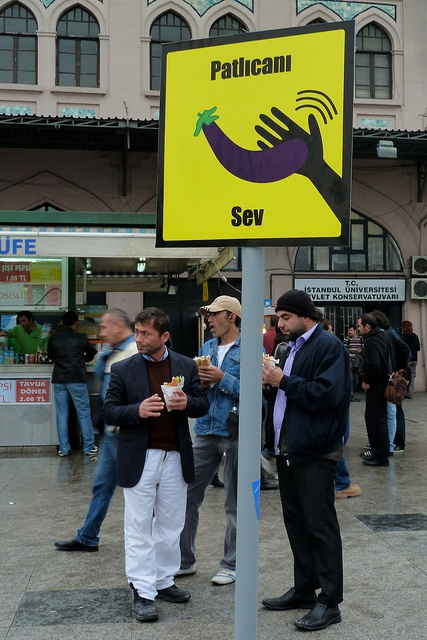Describe the objects in this image and their specific colors. I can see people in gray, black, darkgray, and lavender tones, people in gray, black, and navy tones, people in gray, black, blue, and navy tones, people in gray, black, navy, and blue tones, and people in gray, black, blue, and darkblue tones in this image. 